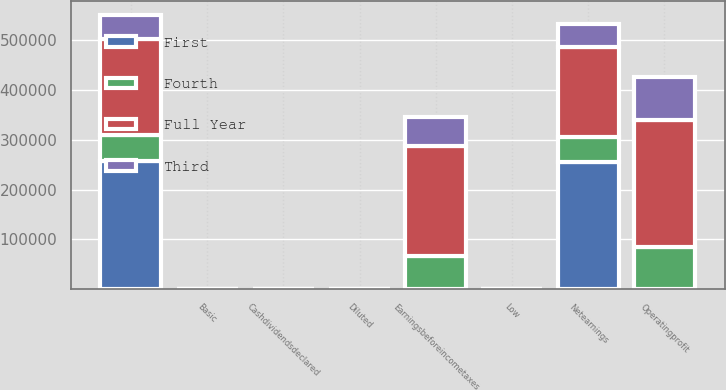<chart> <loc_0><loc_0><loc_500><loc_500><stacked_bar_chart><ecel><fcel>Operatingprofit<fcel>Earningsbeforeincometaxes<fcel>Netearnings<fcel>Unnamed: 4<fcel>Basic<fcel>Diluted<fcel>Low<fcel>Cashdividendsdeclared<nl><fcel>Third<fcel>85916<fcel>59213<fcel>46971<fcel>48751<fcel>0.39<fcel>0.38<fcel>66.96<fcel>0.51<nl><fcel>Fourth<fcel>84874<fcel>67020<fcel>49419<fcel>52106<fcel>0.42<fcel>0.41<fcel>77.8<fcel>0.51<nl><fcel>First<fcel>77.535<fcel>77.535<fcel>256162<fcel>257798<fcel>2.05<fcel>2.03<fcel>76.16<fcel>0.51<nl><fcel>Full Year<fcel>255157<fcel>219932<fcel>180599<fcel>192725<fcel>1.54<fcel>1.52<fcel>77.27<fcel>0.51<nl></chart> 